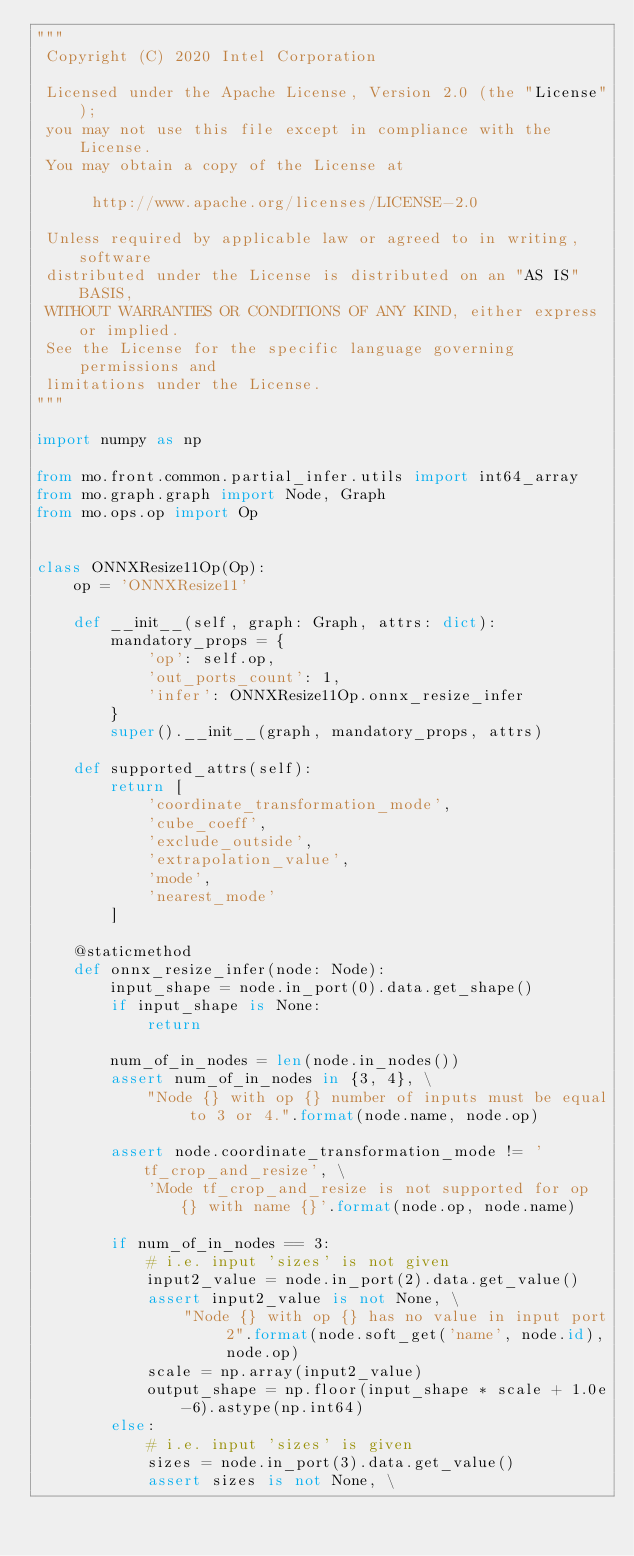Convert code to text. <code><loc_0><loc_0><loc_500><loc_500><_Python_>"""
 Copyright (C) 2020 Intel Corporation

 Licensed under the Apache License, Version 2.0 (the "License");
 you may not use this file except in compliance with the License.
 You may obtain a copy of the License at

      http://www.apache.org/licenses/LICENSE-2.0

 Unless required by applicable law or agreed to in writing, software
 distributed under the License is distributed on an "AS IS" BASIS,
 WITHOUT WARRANTIES OR CONDITIONS OF ANY KIND, either express or implied.
 See the License for the specific language governing permissions and
 limitations under the License.
"""

import numpy as np

from mo.front.common.partial_infer.utils import int64_array
from mo.graph.graph import Node, Graph
from mo.ops.op import Op


class ONNXResize11Op(Op):
    op = 'ONNXResize11'

    def __init__(self, graph: Graph, attrs: dict):
        mandatory_props = {
            'op': self.op,
            'out_ports_count': 1,
            'infer': ONNXResize11Op.onnx_resize_infer
        }
        super().__init__(graph, mandatory_props, attrs)

    def supported_attrs(self):
        return [
            'coordinate_transformation_mode',
            'cube_coeff',
            'exclude_outside',
            'extrapolation_value',
            'mode',
            'nearest_mode'
        ]

    @staticmethod
    def onnx_resize_infer(node: Node):
        input_shape = node.in_port(0).data.get_shape()
        if input_shape is None:
            return

        num_of_in_nodes = len(node.in_nodes())
        assert num_of_in_nodes in {3, 4}, \
            "Node {} with op {} number of inputs must be equal to 3 or 4.".format(node.name, node.op)

        assert node.coordinate_transformation_mode != 'tf_crop_and_resize', \
            'Mode tf_crop_and_resize is not supported for op {} with name {}'.format(node.op, node.name)

        if num_of_in_nodes == 3:
            # i.e. input 'sizes' is not given
            input2_value = node.in_port(2).data.get_value()
            assert input2_value is not None, \
                "Node {} with op {} has no value in input port 2".format(node.soft_get('name', node.id), node.op)
            scale = np.array(input2_value)
            output_shape = np.floor(input_shape * scale + 1.0e-6).astype(np.int64)
        else:
            # i.e. input 'sizes' is given
            sizes = node.in_port(3).data.get_value()
            assert sizes is not None, \</code> 